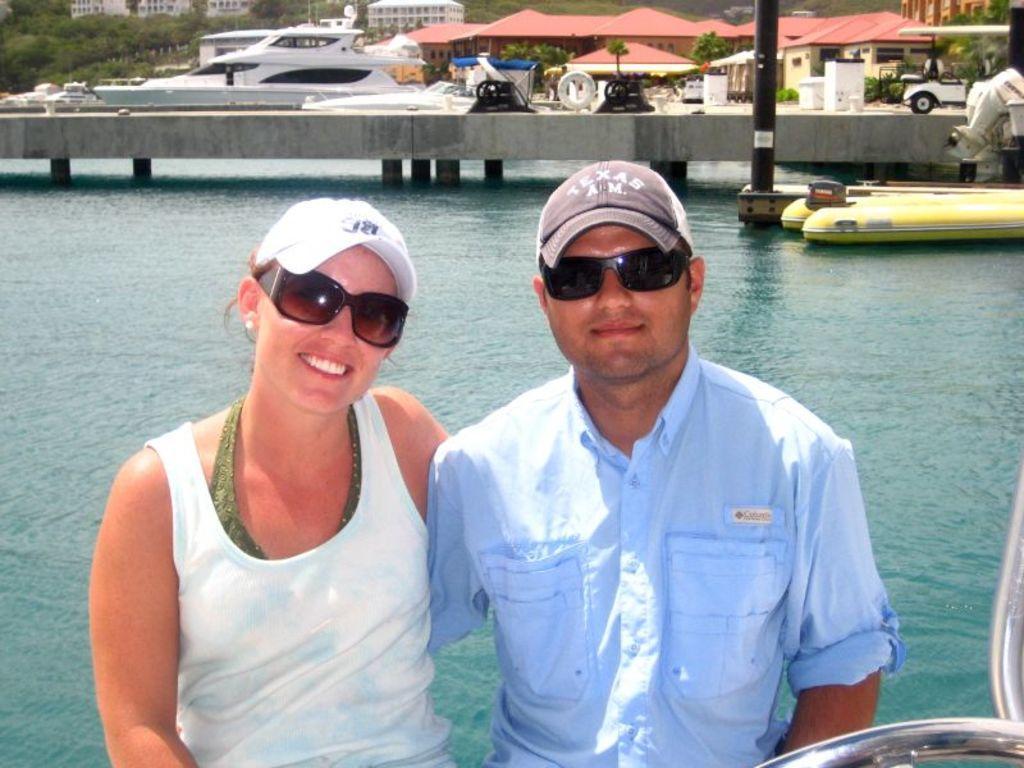Could you give a brief overview of what you see in this image? In this picture there is a man who is wearing cap, goggles and shirt. He is standing near to the woman who is wearing goggles, cap and t-shirt. Both of them are standing near to this steel pipe. In the back we can see the water. Near to the bridge we can see boats and black color pole. In the background we can see boats, building, vehicle, trees, plants and mountain. 